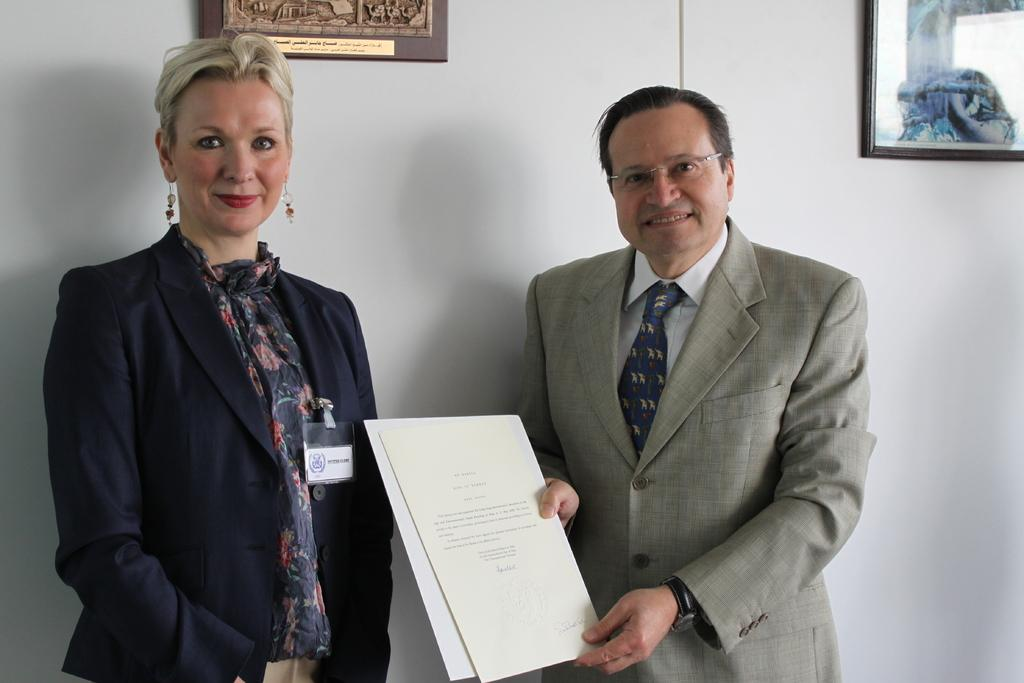How many people are present in the image? There are two people, a man and a woman, present in the image. What is the man holding in the image? The man is holding papers. What can be seen in the background of the image? There is a wall in the background of the image. What is hanging on the wall in the image? There are frames on the wall. Can you see any signs of wealth in the image? The provided facts do not mention any signs of wealth, so it cannot be determined from the image. Are the man and woman kissing in the image? There is no indication in the image that the man and woman are kissing. 